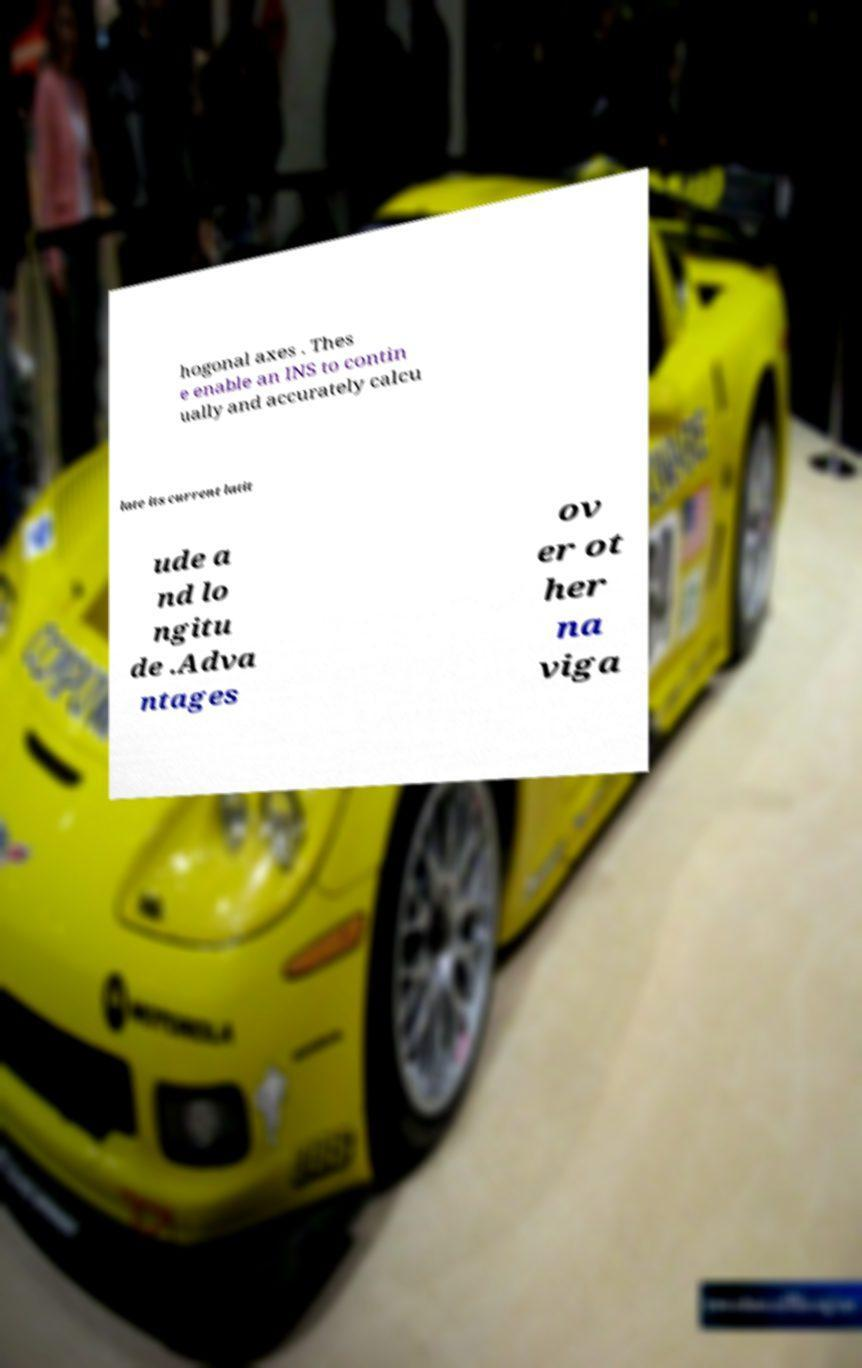Could you extract and type out the text from this image? hogonal axes . Thes e enable an INS to contin ually and accurately calcu late its current latit ude a nd lo ngitu de .Adva ntages ov er ot her na viga 